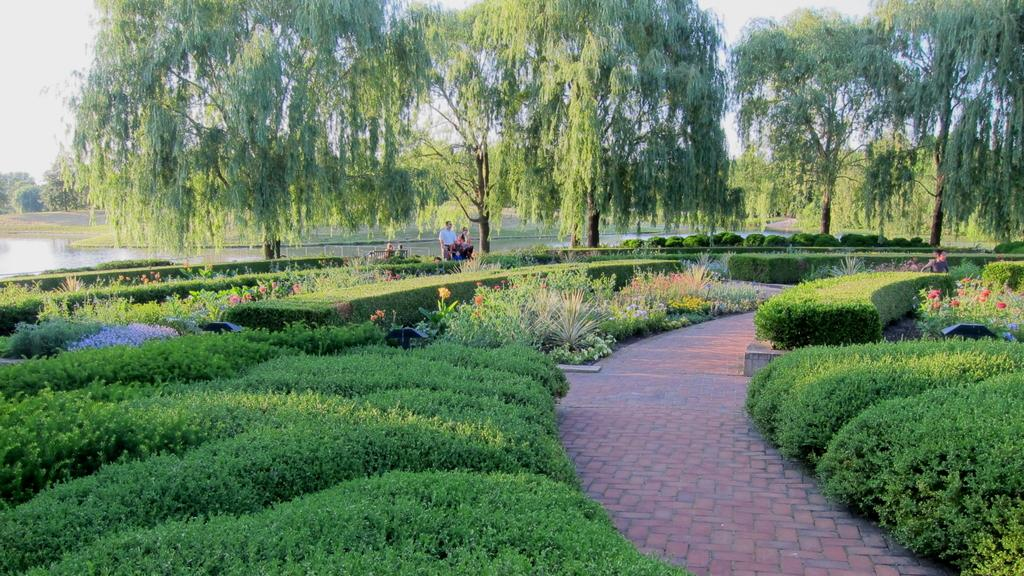What type of vegetation is at the bottom of the image? There is grass, plants, and flowers at the bottom of the image. What is located at the bottom of the image besides vegetation? There is a walkway at the bottom of the image. What can be seen in the background of the image? There is a pond, trees, and people in the background of the image. What is visible at the top of the image? The sky is visible at the top of the image. How many kitties are jumping into the pond in the image? There are no kitties present in the image, and they are not jumping into the pond. What type of bucket is being used by the people in the background of the image? There is no bucket visible in the image; the people are not using any buckets. 